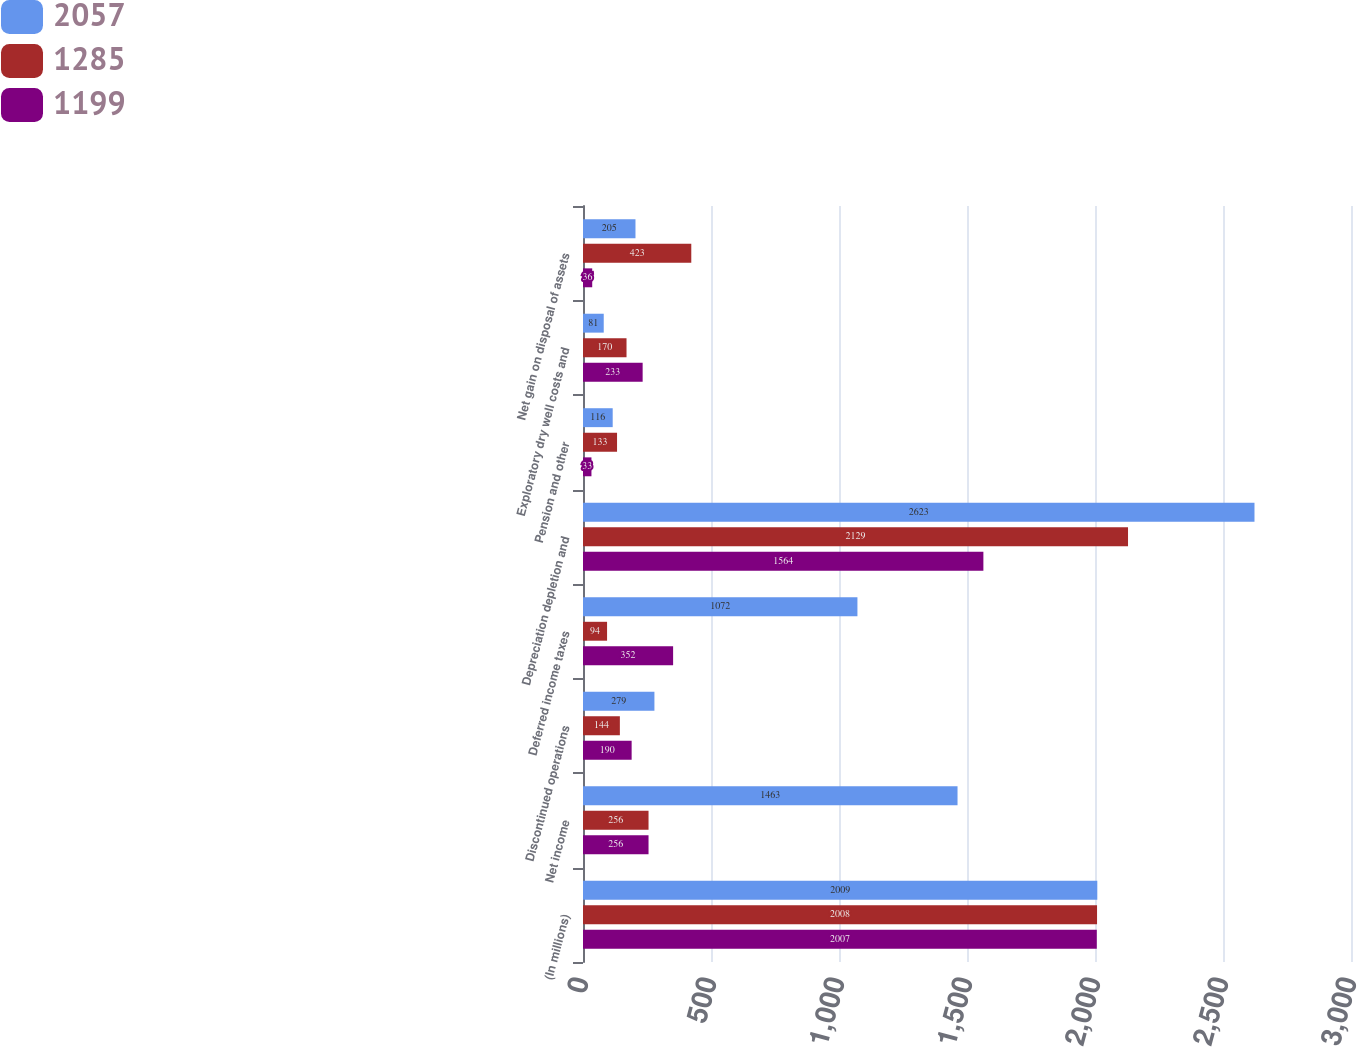Convert chart. <chart><loc_0><loc_0><loc_500><loc_500><stacked_bar_chart><ecel><fcel>(In millions)<fcel>Net income<fcel>Discontinued operations<fcel>Deferred income taxes<fcel>Depreciation depletion and<fcel>Pension and other<fcel>Exploratory dry well costs and<fcel>Net gain on disposal of assets<nl><fcel>2057<fcel>2009<fcel>1463<fcel>279<fcel>1072<fcel>2623<fcel>116<fcel>81<fcel>205<nl><fcel>1285<fcel>2008<fcel>256<fcel>144<fcel>94<fcel>2129<fcel>133<fcel>170<fcel>423<nl><fcel>1199<fcel>2007<fcel>256<fcel>190<fcel>352<fcel>1564<fcel>33<fcel>233<fcel>36<nl></chart> 